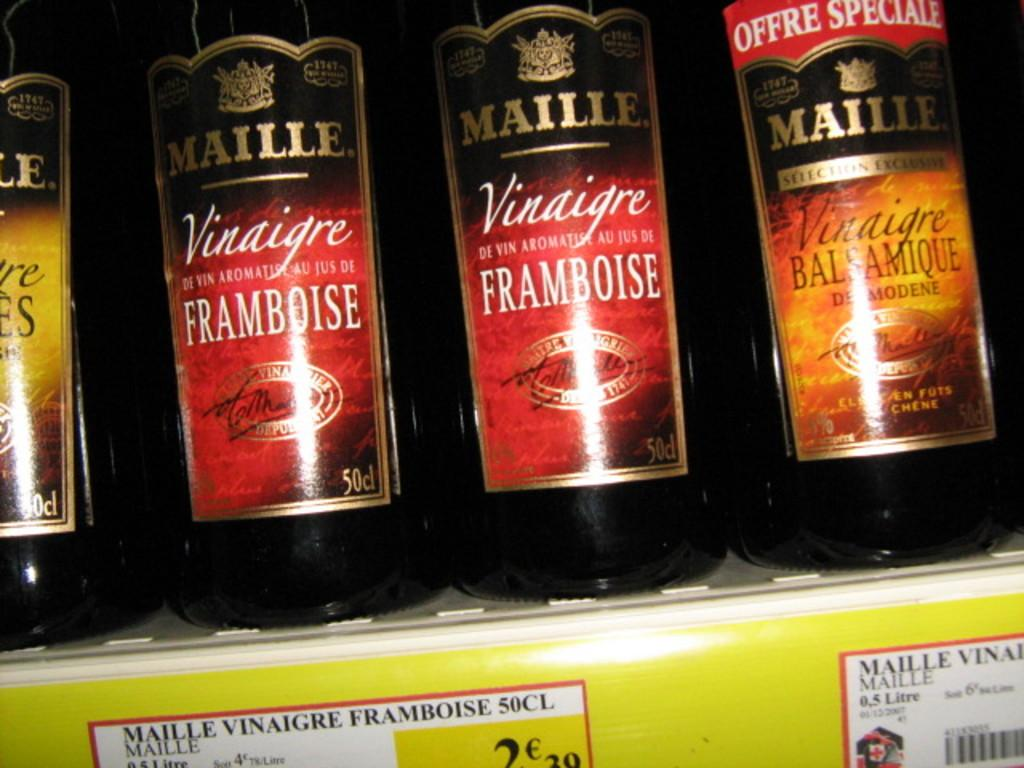<image>
Create a compact narrative representing the image presented. Several bottles of Maille Vinaigre sit on a shelf, one having an offre speciale 